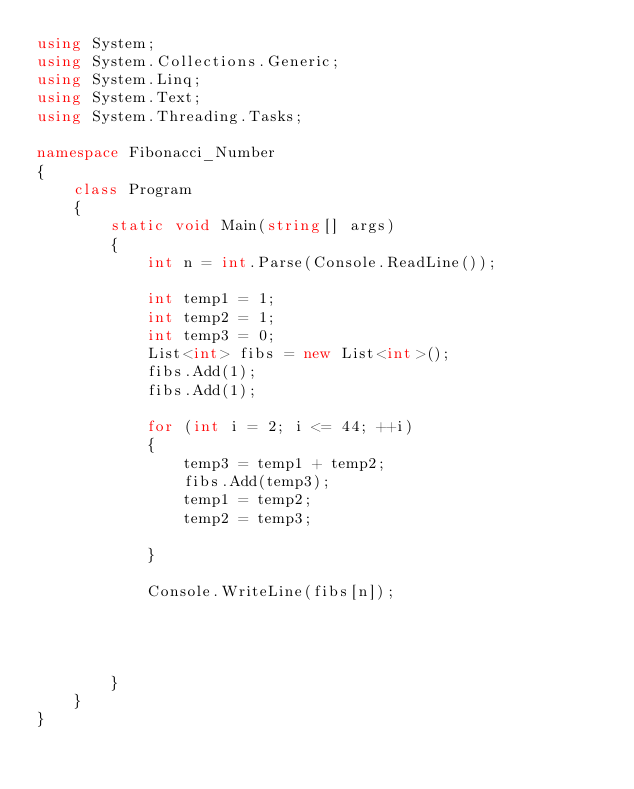<code> <loc_0><loc_0><loc_500><loc_500><_C#_>using System;
using System.Collections.Generic;
using System.Linq;
using System.Text;
using System.Threading.Tasks;

namespace Fibonacci_Number
{
    class Program
    {
        static void Main(string[] args)
        {
            int n = int.Parse(Console.ReadLine());

            int temp1 = 1;
            int temp2 = 1;
            int temp3 = 0;
            List<int> fibs = new List<int>();
            fibs.Add(1);
            fibs.Add(1);

            for (int i = 2; i <= 44; ++i)
            {
                temp3 = temp1 + temp2;
                fibs.Add(temp3);
                temp1 = temp2;
                temp2 = temp3;

            }

            Console.WriteLine(fibs[n]);




        }
    }
}

</code> 